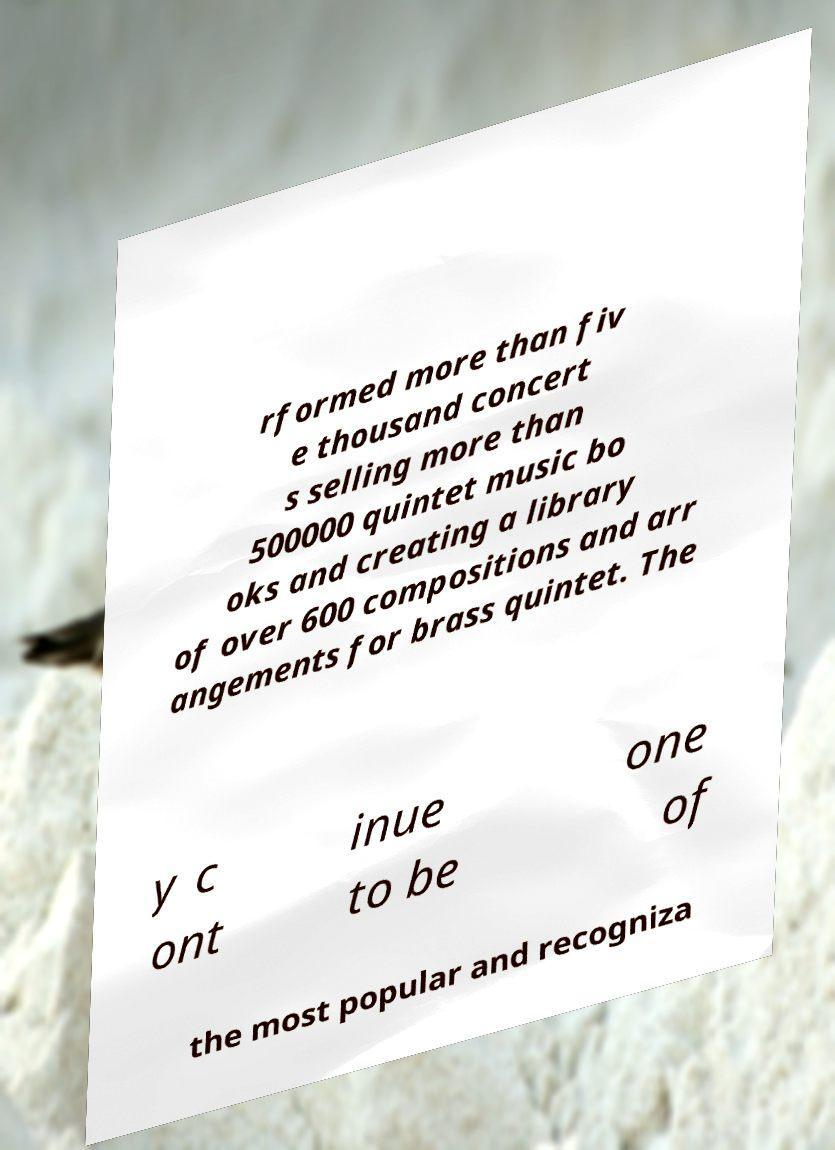I need the written content from this picture converted into text. Can you do that? rformed more than fiv e thousand concert s selling more than 500000 quintet music bo oks and creating a library of over 600 compositions and arr angements for brass quintet. The y c ont inue to be one of the most popular and recogniza 